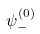<formula> <loc_0><loc_0><loc_500><loc_500>\psi _ { - } ^ { ( 0 ) }</formula> 